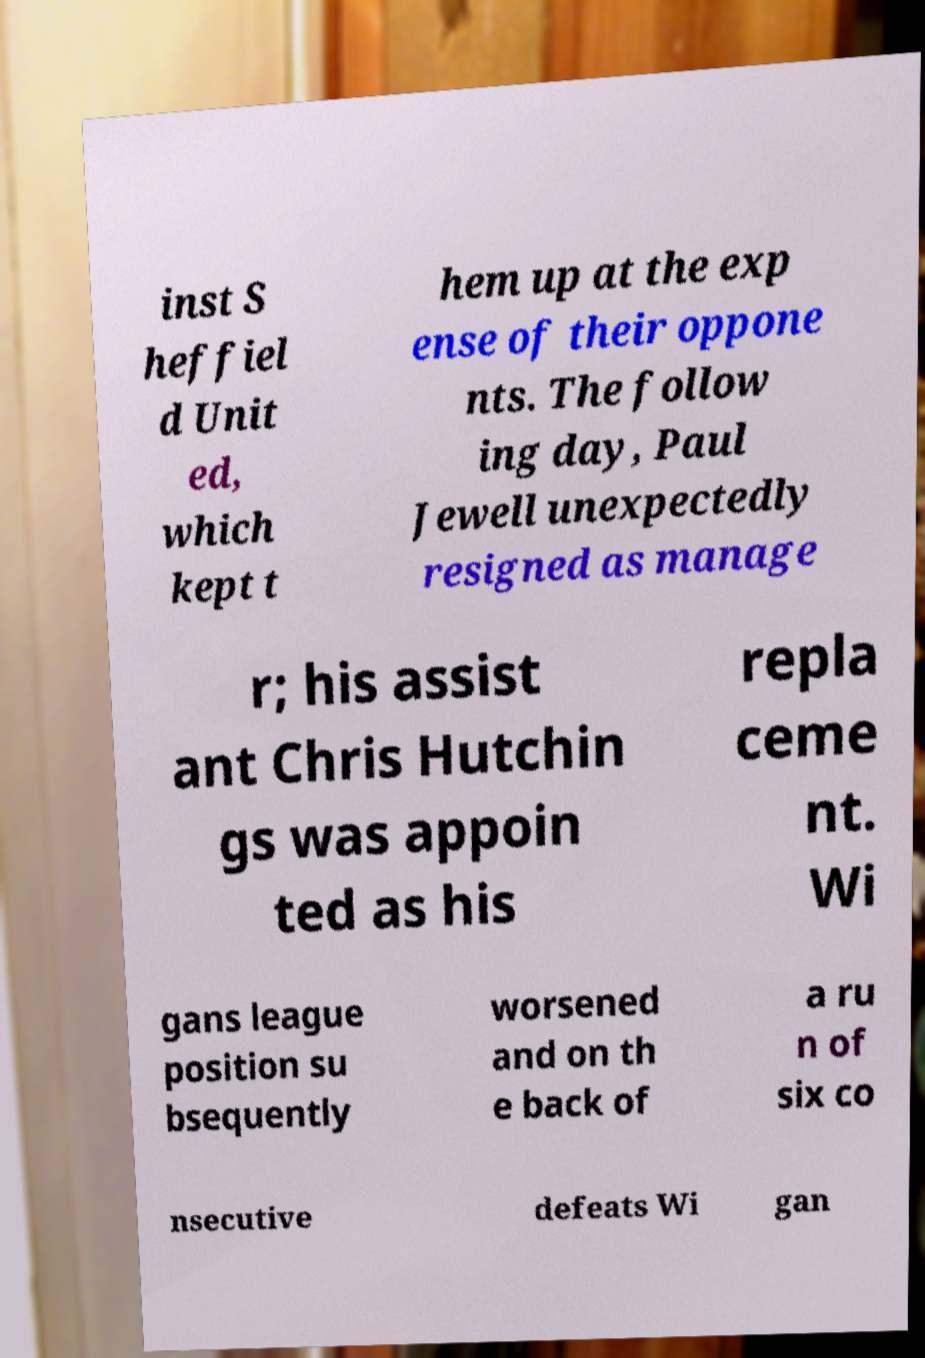What messages or text are displayed in this image? I need them in a readable, typed format. inst S heffiel d Unit ed, which kept t hem up at the exp ense of their oppone nts. The follow ing day, Paul Jewell unexpectedly resigned as manage r; his assist ant Chris Hutchin gs was appoin ted as his repla ceme nt. Wi gans league position su bsequently worsened and on th e back of a ru n of six co nsecutive defeats Wi gan 